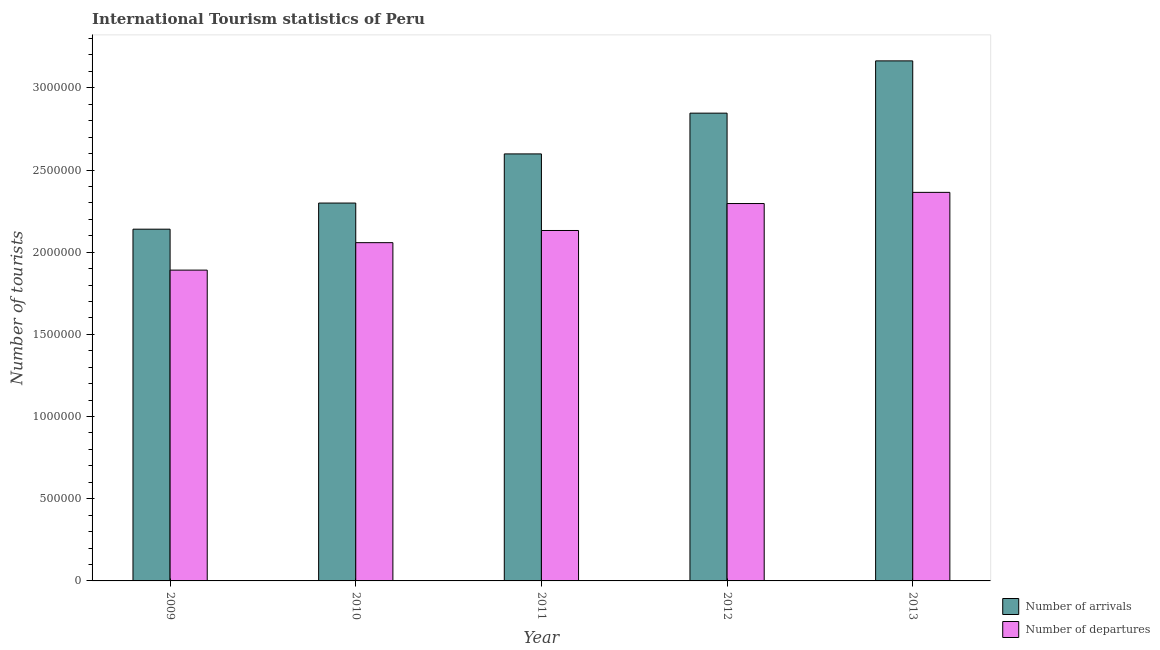How many different coloured bars are there?
Give a very brief answer. 2. How many groups of bars are there?
Give a very brief answer. 5. How many bars are there on the 3rd tick from the left?
Your response must be concise. 2. In how many cases, is the number of bars for a given year not equal to the number of legend labels?
Provide a succinct answer. 0. What is the number of tourist departures in 2010?
Make the answer very short. 2.06e+06. Across all years, what is the maximum number of tourist departures?
Offer a very short reply. 2.36e+06. Across all years, what is the minimum number of tourist arrivals?
Your response must be concise. 2.14e+06. In which year was the number of tourist arrivals maximum?
Your answer should be compact. 2013. What is the total number of tourist departures in the graph?
Ensure brevity in your answer.  1.07e+07. What is the difference between the number of tourist arrivals in 2012 and that in 2013?
Ensure brevity in your answer.  -3.18e+05. What is the difference between the number of tourist departures in 2012 and the number of tourist arrivals in 2011?
Ensure brevity in your answer.  1.64e+05. What is the average number of tourist departures per year?
Ensure brevity in your answer.  2.15e+06. What is the ratio of the number of tourist departures in 2012 to that in 2013?
Your response must be concise. 0.97. Is the number of tourist departures in 2009 less than that in 2011?
Offer a terse response. Yes. What is the difference between the highest and the second highest number of tourist departures?
Make the answer very short. 6.80e+04. What is the difference between the highest and the lowest number of tourist arrivals?
Make the answer very short. 1.02e+06. In how many years, is the number of tourist departures greater than the average number of tourist departures taken over all years?
Provide a succinct answer. 2. Is the sum of the number of tourist departures in 2010 and 2011 greater than the maximum number of tourist arrivals across all years?
Offer a very short reply. Yes. What does the 2nd bar from the left in 2013 represents?
Provide a succinct answer. Number of departures. What does the 1st bar from the right in 2013 represents?
Your answer should be compact. Number of departures. Are the values on the major ticks of Y-axis written in scientific E-notation?
Offer a terse response. No. Does the graph contain any zero values?
Your response must be concise. No. Does the graph contain grids?
Offer a very short reply. No. How are the legend labels stacked?
Provide a short and direct response. Vertical. What is the title of the graph?
Provide a short and direct response. International Tourism statistics of Peru. Does "Secondary" appear as one of the legend labels in the graph?
Your answer should be compact. No. What is the label or title of the X-axis?
Your response must be concise. Year. What is the label or title of the Y-axis?
Offer a very short reply. Number of tourists. What is the Number of tourists of Number of arrivals in 2009?
Offer a terse response. 2.14e+06. What is the Number of tourists in Number of departures in 2009?
Give a very brief answer. 1.89e+06. What is the Number of tourists in Number of arrivals in 2010?
Your answer should be very brief. 2.30e+06. What is the Number of tourists in Number of departures in 2010?
Your answer should be compact. 2.06e+06. What is the Number of tourists of Number of arrivals in 2011?
Keep it short and to the point. 2.60e+06. What is the Number of tourists of Number of departures in 2011?
Give a very brief answer. 2.13e+06. What is the Number of tourists of Number of arrivals in 2012?
Make the answer very short. 2.85e+06. What is the Number of tourists of Number of departures in 2012?
Your answer should be compact. 2.30e+06. What is the Number of tourists of Number of arrivals in 2013?
Give a very brief answer. 3.16e+06. What is the Number of tourists of Number of departures in 2013?
Give a very brief answer. 2.36e+06. Across all years, what is the maximum Number of tourists of Number of arrivals?
Ensure brevity in your answer.  3.16e+06. Across all years, what is the maximum Number of tourists of Number of departures?
Your answer should be very brief. 2.36e+06. Across all years, what is the minimum Number of tourists of Number of arrivals?
Offer a very short reply. 2.14e+06. Across all years, what is the minimum Number of tourists of Number of departures?
Provide a short and direct response. 1.89e+06. What is the total Number of tourists of Number of arrivals in the graph?
Give a very brief answer. 1.30e+07. What is the total Number of tourists of Number of departures in the graph?
Provide a short and direct response. 1.07e+07. What is the difference between the Number of tourists of Number of arrivals in 2009 and that in 2010?
Your response must be concise. -1.59e+05. What is the difference between the Number of tourists of Number of departures in 2009 and that in 2010?
Offer a terse response. -1.67e+05. What is the difference between the Number of tourists in Number of arrivals in 2009 and that in 2011?
Provide a succinct answer. -4.58e+05. What is the difference between the Number of tourists of Number of departures in 2009 and that in 2011?
Ensure brevity in your answer.  -2.41e+05. What is the difference between the Number of tourists of Number of arrivals in 2009 and that in 2012?
Make the answer very short. -7.06e+05. What is the difference between the Number of tourists in Number of departures in 2009 and that in 2012?
Ensure brevity in your answer.  -4.05e+05. What is the difference between the Number of tourists of Number of arrivals in 2009 and that in 2013?
Make the answer very short. -1.02e+06. What is the difference between the Number of tourists in Number of departures in 2009 and that in 2013?
Make the answer very short. -4.73e+05. What is the difference between the Number of tourists of Number of arrivals in 2010 and that in 2011?
Your response must be concise. -2.99e+05. What is the difference between the Number of tourists of Number of departures in 2010 and that in 2011?
Offer a very short reply. -7.40e+04. What is the difference between the Number of tourists in Number of arrivals in 2010 and that in 2012?
Offer a very short reply. -5.47e+05. What is the difference between the Number of tourists in Number of departures in 2010 and that in 2012?
Offer a very short reply. -2.38e+05. What is the difference between the Number of tourists of Number of arrivals in 2010 and that in 2013?
Your answer should be compact. -8.65e+05. What is the difference between the Number of tourists of Number of departures in 2010 and that in 2013?
Make the answer very short. -3.06e+05. What is the difference between the Number of tourists in Number of arrivals in 2011 and that in 2012?
Your answer should be compact. -2.48e+05. What is the difference between the Number of tourists of Number of departures in 2011 and that in 2012?
Provide a succinct answer. -1.64e+05. What is the difference between the Number of tourists in Number of arrivals in 2011 and that in 2013?
Your response must be concise. -5.66e+05. What is the difference between the Number of tourists of Number of departures in 2011 and that in 2013?
Keep it short and to the point. -2.32e+05. What is the difference between the Number of tourists of Number of arrivals in 2012 and that in 2013?
Your response must be concise. -3.18e+05. What is the difference between the Number of tourists of Number of departures in 2012 and that in 2013?
Ensure brevity in your answer.  -6.80e+04. What is the difference between the Number of tourists in Number of arrivals in 2009 and the Number of tourists in Number of departures in 2010?
Provide a succinct answer. 8.20e+04. What is the difference between the Number of tourists of Number of arrivals in 2009 and the Number of tourists of Number of departures in 2011?
Make the answer very short. 8000. What is the difference between the Number of tourists in Number of arrivals in 2009 and the Number of tourists in Number of departures in 2012?
Offer a terse response. -1.56e+05. What is the difference between the Number of tourists in Number of arrivals in 2009 and the Number of tourists in Number of departures in 2013?
Your answer should be compact. -2.24e+05. What is the difference between the Number of tourists in Number of arrivals in 2010 and the Number of tourists in Number of departures in 2011?
Offer a terse response. 1.67e+05. What is the difference between the Number of tourists of Number of arrivals in 2010 and the Number of tourists of Number of departures in 2012?
Offer a very short reply. 3000. What is the difference between the Number of tourists of Number of arrivals in 2010 and the Number of tourists of Number of departures in 2013?
Make the answer very short. -6.50e+04. What is the difference between the Number of tourists of Number of arrivals in 2011 and the Number of tourists of Number of departures in 2012?
Give a very brief answer. 3.02e+05. What is the difference between the Number of tourists in Number of arrivals in 2011 and the Number of tourists in Number of departures in 2013?
Offer a terse response. 2.34e+05. What is the difference between the Number of tourists in Number of arrivals in 2012 and the Number of tourists in Number of departures in 2013?
Provide a succinct answer. 4.82e+05. What is the average Number of tourists of Number of arrivals per year?
Provide a succinct answer. 2.61e+06. What is the average Number of tourists of Number of departures per year?
Ensure brevity in your answer.  2.15e+06. In the year 2009, what is the difference between the Number of tourists of Number of arrivals and Number of tourists of Number of departures?
Your answer should be compact. 2.49e+05. In the year 2010, what is the difference between the Number of tourists in Number of arrivals and Number of tourists in Number of departures?
Your answer should be very brief. 2.41e+05. In the year 2011, what is the difference between the Number of tourists in Number of arrivals and Number of tourists in Number of departures?
Keep it short and to the point. 4.66e+05. In the year 2013, what is the difference between the Number of tourists in Number of arrivals and Number of tourists in Number of departures?
Give a very brief answer. 8.00e+05. What is the ratio of the Number of tourists of Number of arrivals in 2009 to that in 2010?
Give a very brief answer. 0.93. What is the ratio of the Number of tourists in Number of departures in 2009 to that in 2010?
Make the answer very short. 0.92. What is the ratio of the Number of tourists in Number of arrivals in 2009 to that in 2011?
Offer a very short reply. 0.82. What is the ratio of the Number of tourists in Number of departures in 2009 to that in 2011?
Provide a succinct answer. 0.89. What is the ratio of the Number of tourists in Number of arrivals in 2009 to that in 2012?
Provide a short and direct response. 0.75. What is the ratio of the Number of tourists in Number of departures in 2009 to that in 2012?
Ensure brevity in your answer.  0.82. What is the ratio of the Number of tourists in Number of arrivals in 2009 to that in 2013?
Provide a short and direct response. 0.68. What is the ratio of the Number of tourists in Number of departures in 2009 to that in 2013?
Give a very brief answer. 0.8. What is the ratio of the Number of tourists in Number of arrivals in 2010 to that in 2011?
Your answer should be very brief. 0.88. What is the ratio of the Number of tourists in Number of departures in 2010 to that in 2011?
Give a very brief answer. 0.97. What is the ratio of the Number of tourists in Number of arrivals in 2010 to that in 2012?
Provide a succinct answer. 0.81. What is the ratio of the Number of tourists in Number of departures in 2010 to that in 2012?
Provide a short and direct response. 0.9. What is the ratio of the Number of tourists of Number of arrivals in 2010 to that in 2013?
Provide a succinct answer. 0.73. What is the ratio of the Number of tourists of Number of departures in 2010 to that in 2013?
Give a very brief answer. 0.87. What is the ratio of the Number of tourists of Number of arrivals in 2011 to that in 2012?
Make the answer very short. 0.91. What is the ratio of the Number of tourists in Number of departures in 2011 to that in 2012?
Provide a short and direct response. 0.93. What is the ratio of the Number of tourists of Number of arrivals in 2011 to that in 2013?
Offer a terse response. 0.82. What is the ratio of the Number of tourists of Number of departures in 2011 to that in 2013?
Make the answer very short. 0.9. What is the ratio of the Number of tourists in Number of arrivals in 2012 to that in 2013?
Give a very brief answer. 0.9. What is the ratio of the Number of tourists of Number of departures in 2012 to that in 2013?
Your response must be concise. 0.97. What is the difference between the highest and the second highest Number of tourists in Number of arrivals?
Keep it short and to the point. 3.18e+05. What is the difference between the highest and the second highest Number of tourists of Number of departures?
Offer a very short reply. 6.80e+04. What is the difference between the highest and the lowest Number of tourists in Number of arrivals?
Offer a very short reply. 1.02e+06. What is the difference between the highest and the lowest Number of tourists in Number of departures?
Give a very brief answer. 4.73e+05. 